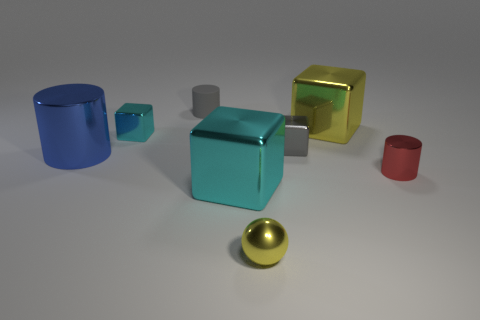Subtract all cyan cubes. How many cubes are left? 2 Subtract all tiny cylinders. How many cylinders are left? 1 Add 1 large yellow rubber cylinders. How many objects exist? 9 Subtract all cylinders. How many objects are left? 5 Subtract all purple cubes. Subtract all blue spheres. How many cubes are left? 4 Subtract all green cylinders. How many yellow blocks are left? 1 Subtract all big blue things. Subtract all cubes. How many objects are left? 3 Add 6 gray matte things. How many gray matte things are left? 7 Add 4 red metallic cylinders. How many red metallic cylinders exist? 5 Subtract 1 blue cylinders. How many objects are left? 7 